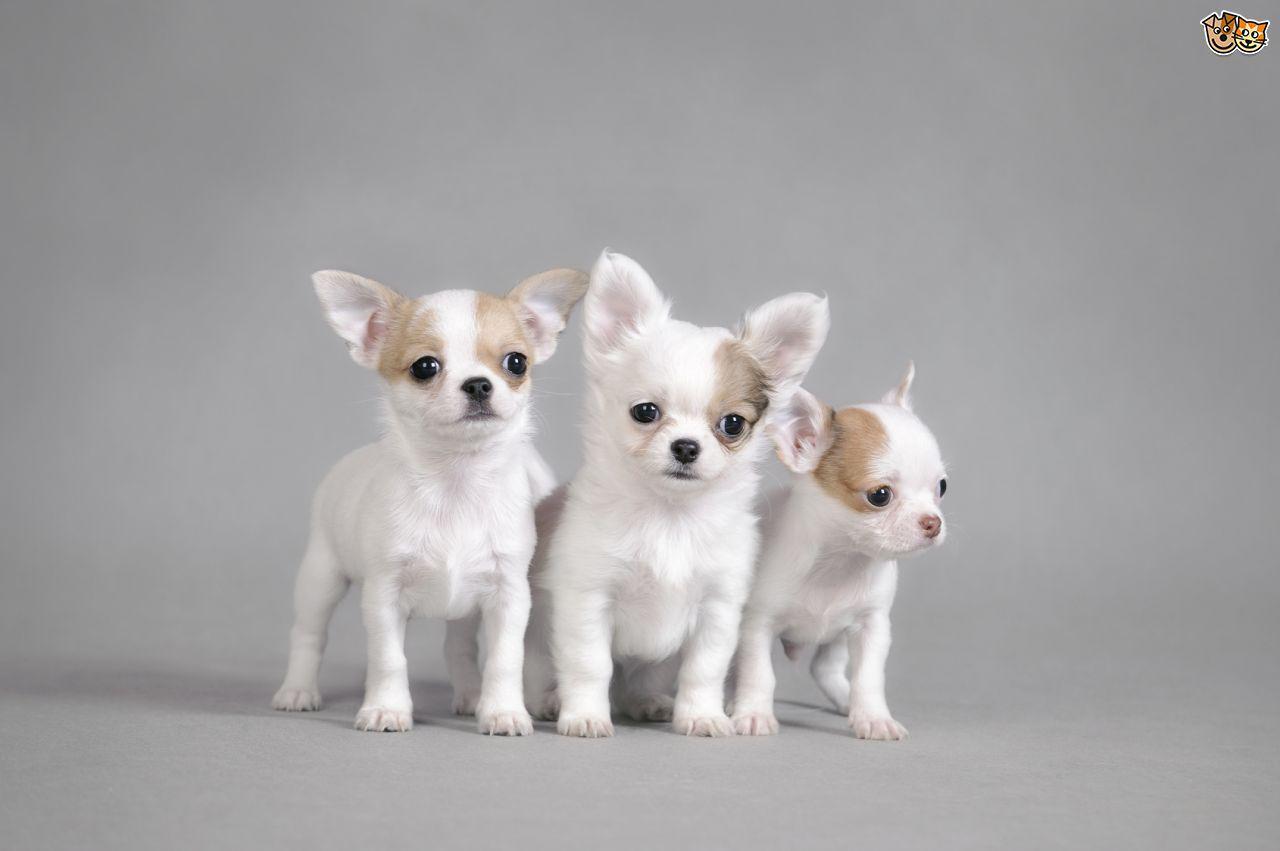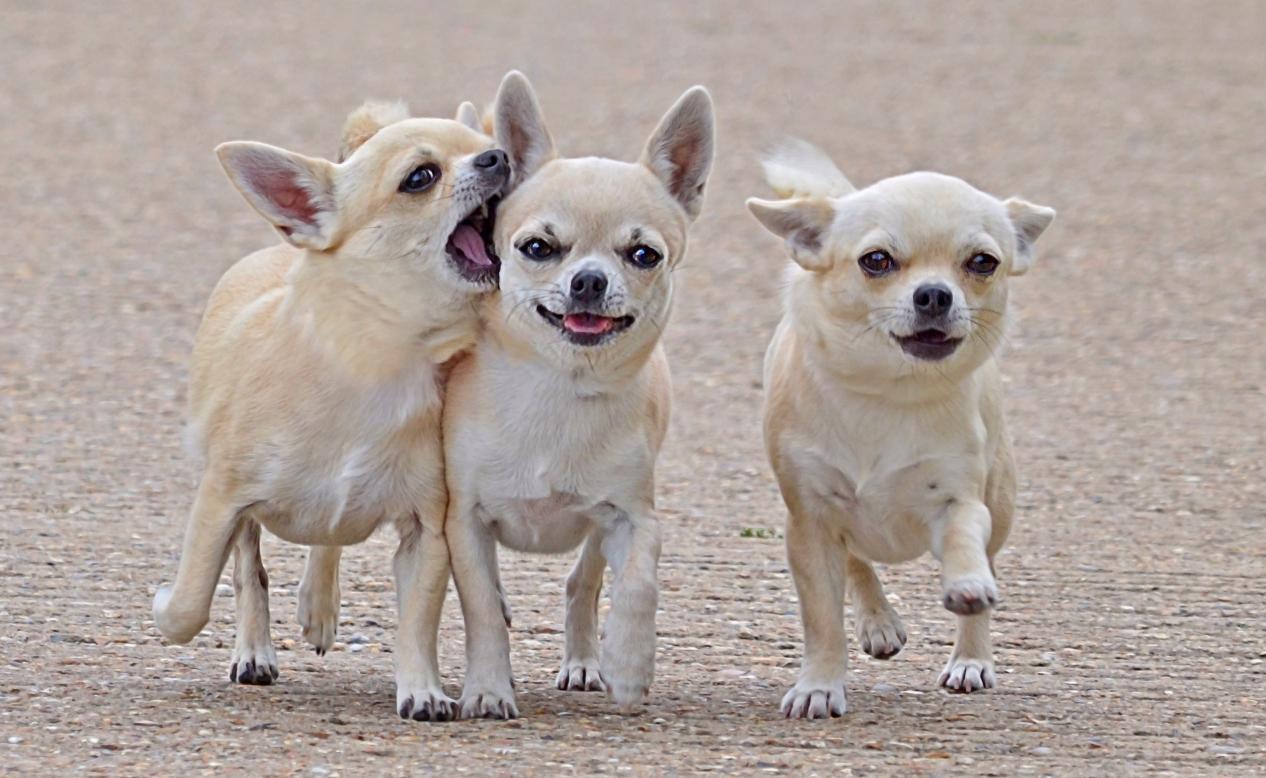The first image is the image on the left, the second image is the image on the right. Analyze the images presented: Is the assertion "There are two chihuahuas." valid? Answer yes or no. No. The first image is the image on the left, the second image is the image on the right. Examine the images to the left and right. Is the description "Each image contains exactly one small dog." accurate? Answer yes or no. No. 